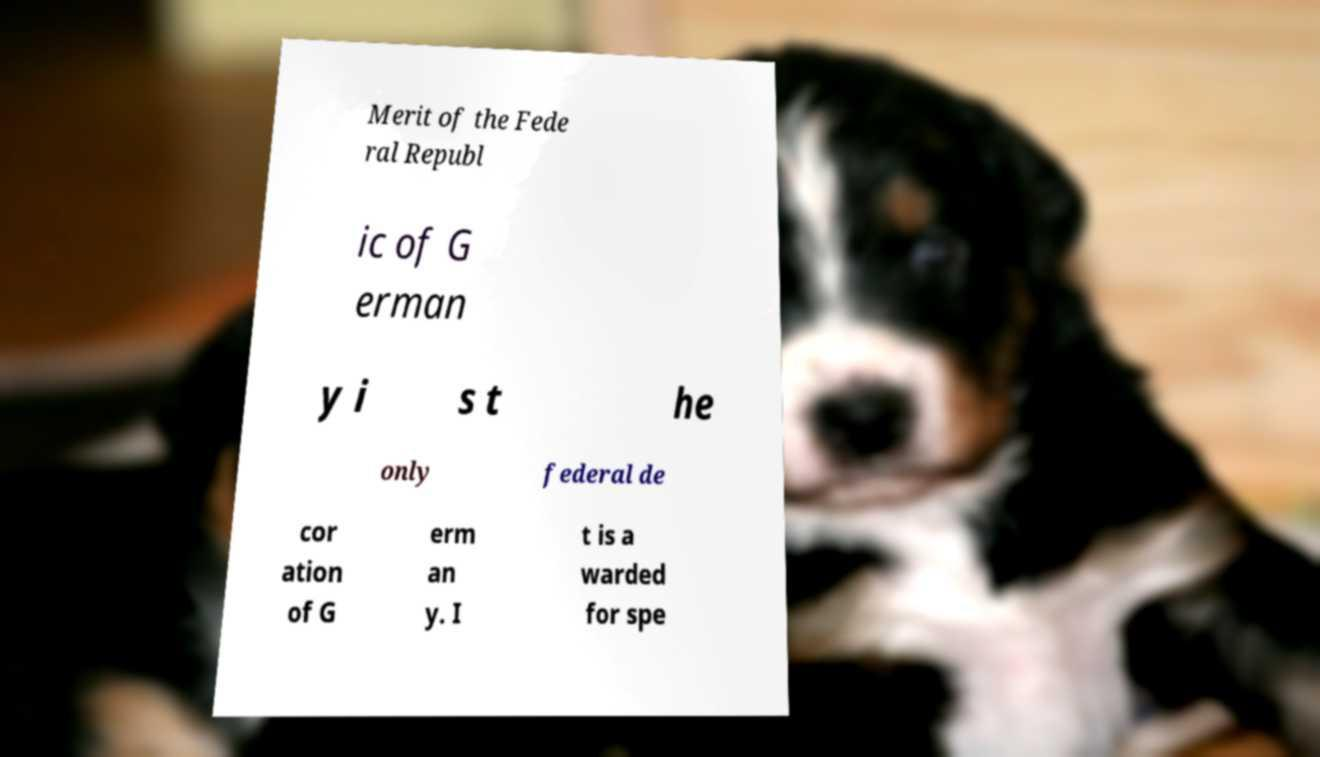Can you accurately transcribe the text from the provided image for me? Merit of the Fede ral Republ ic of G erman y i s t he only federal de cor ation of G erm an y. I t is a warded for spe 